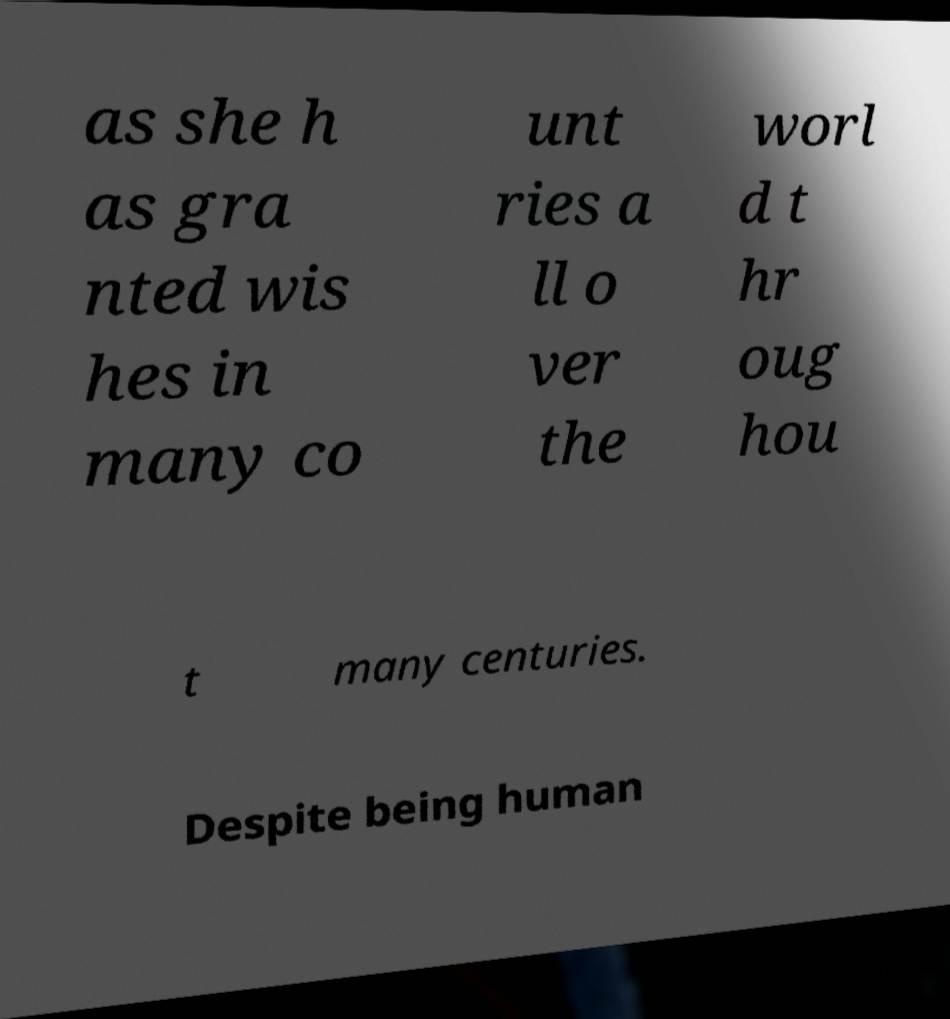Can you read and provide the text displayed in the image?This photo seems to have some interesting text. Can you extract and type it out for me? as she h as gra nted wis hes in many co unt ries a ll o ver the worl d t hr oug hou t many centuries. Despite being human 